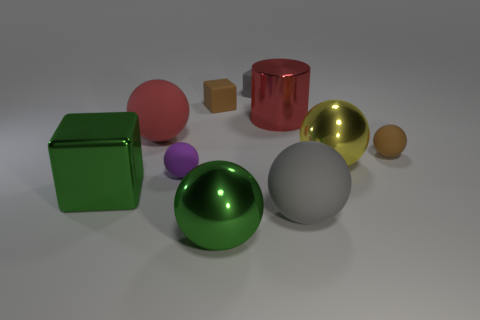Subtract all green spheres. How many spheres are left? 5 Subtract all rubber blocks. How many blocks are left? 1 Subtract all gray balls. Subtract all green cylinders. How many balls are left? 5 Subtract all spheres. How many objects are left? 4 Add 3 cyan rubber cylinders. How many cyan rubber cylinders exist? 3 Subtract 1 purple balls. How many objects are left? 9 Subtract all yellow things. Subtract all gray rubber balls. How many objects are left? 8 Add 4 big matte spheres. How many big matte spheres are left? 6 